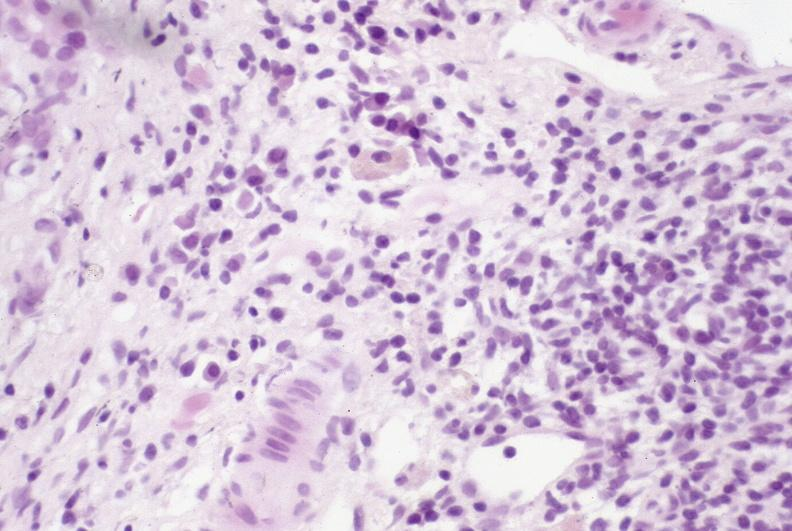what does this image show?
Answer the question using a single word or phrase. Primary sclerosing cholangitis 